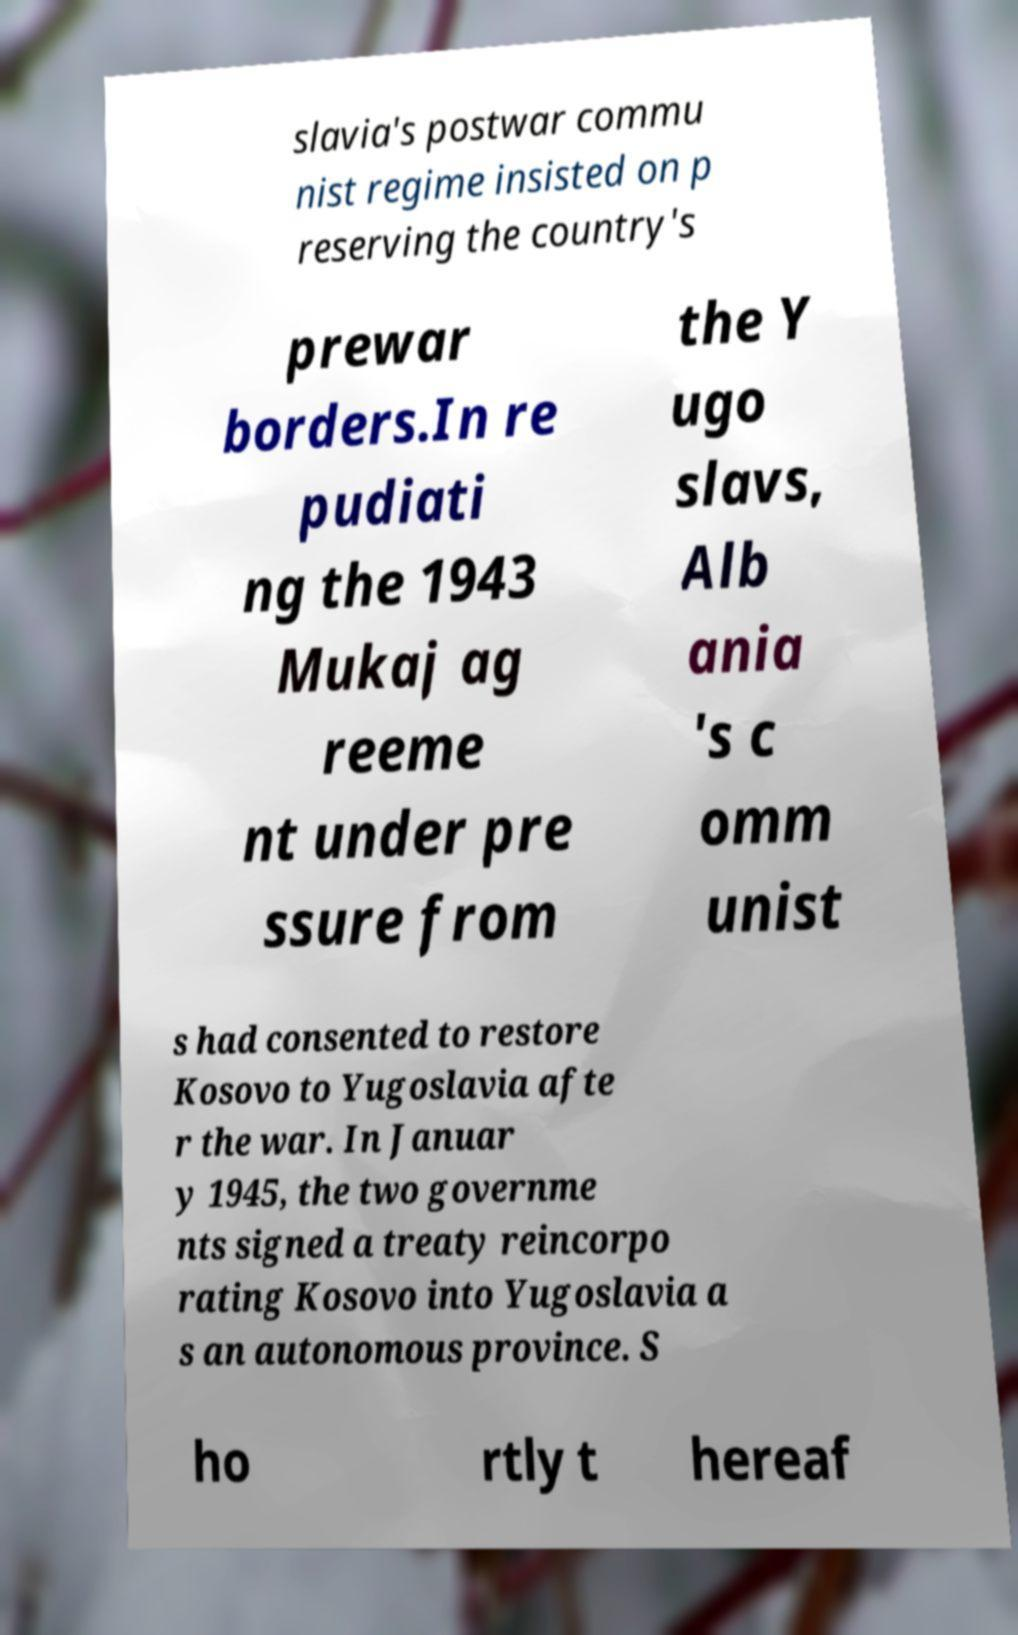For documentation purposes, I need the text within this image transcribed. Could you provide that? slavia's postwar commu nist regime insisted on p reserving the country's prewar borders.In re pudiati ng the 1943 Mukaj ag reeme nt under pre ssure from the Y ugo slavs, Alb ania 's c omm unist s had consented to restore Kosovo to Yugoslavia afte r the war. In Januar y 1945, the two governme nts signed a treaty reincorpo rating Kosovo into Yugoslavia a s an autonomous province. S ho rtly t hereaf 